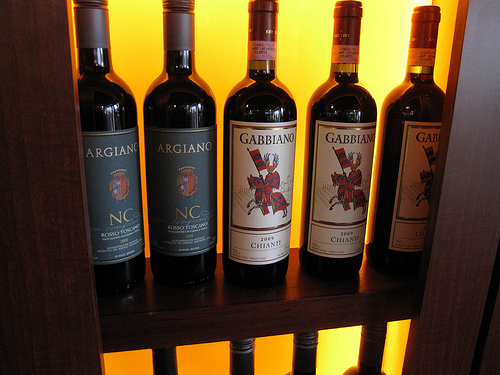<image>
Is there a knight on the wine bottle? Yes. Looking at the image, I can see the knight is positioned on top of the wine bottle, with the wine bottle providing support. 